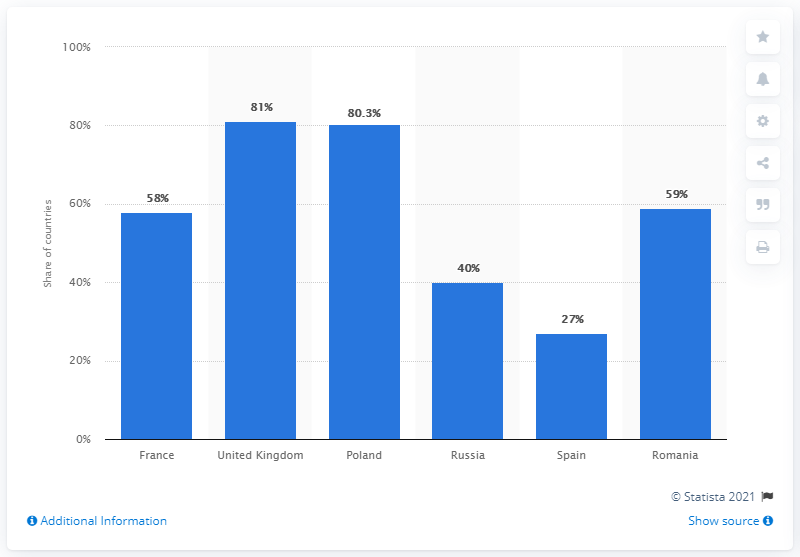Give some essential details in this illustration. Out of the countries considered, 2 have a percentage above 60%. The country with 27% is Spain. 